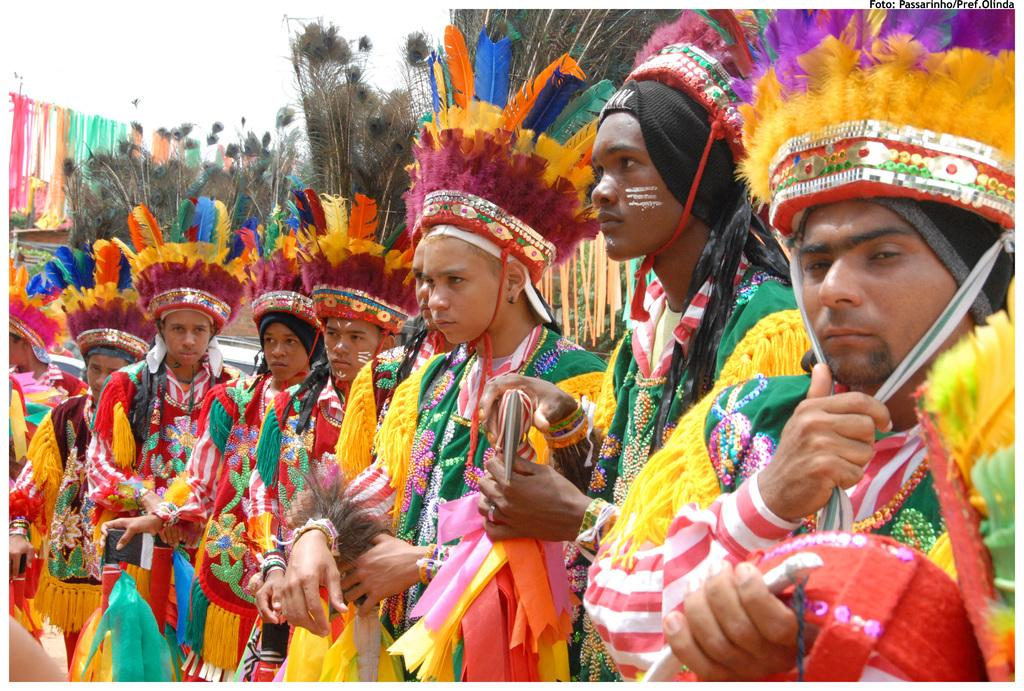How many people are in the image? There is a group of people in the image. What are the people wearing? The people are wearing costumes. Can you describe any specific details about the costumes? Peacock feathers are present in the image, which suggests that the costumes may be related to peacocks or have peacock-inspired elements. What type of mist can be seen surrounding the people in the image? There is no mist present in the image; it features a group of people wearing costumes with peacock feathers. 